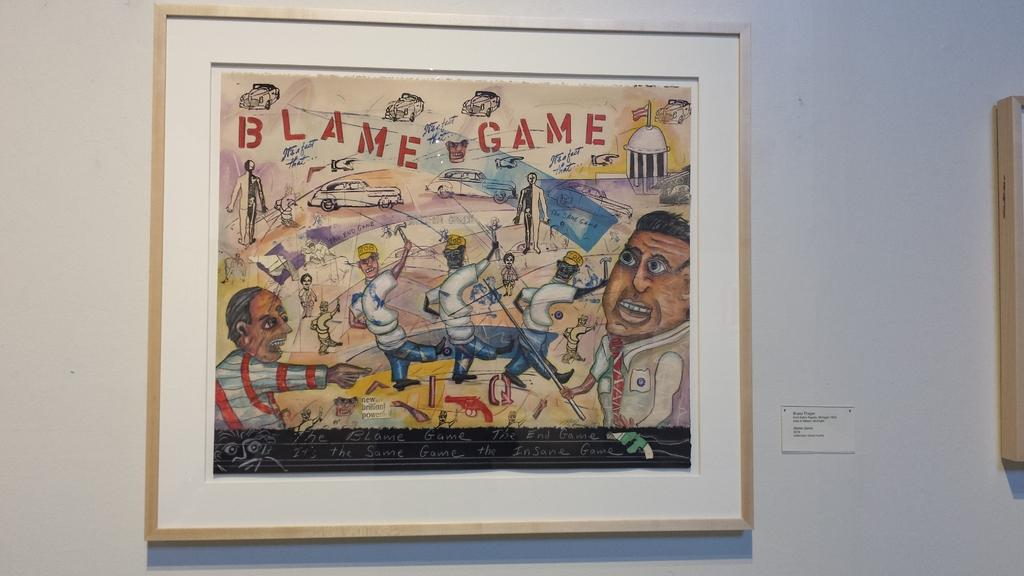<image>
Present a compact description of the photo's key features. A piece of artwork on display is called Blame Game. 